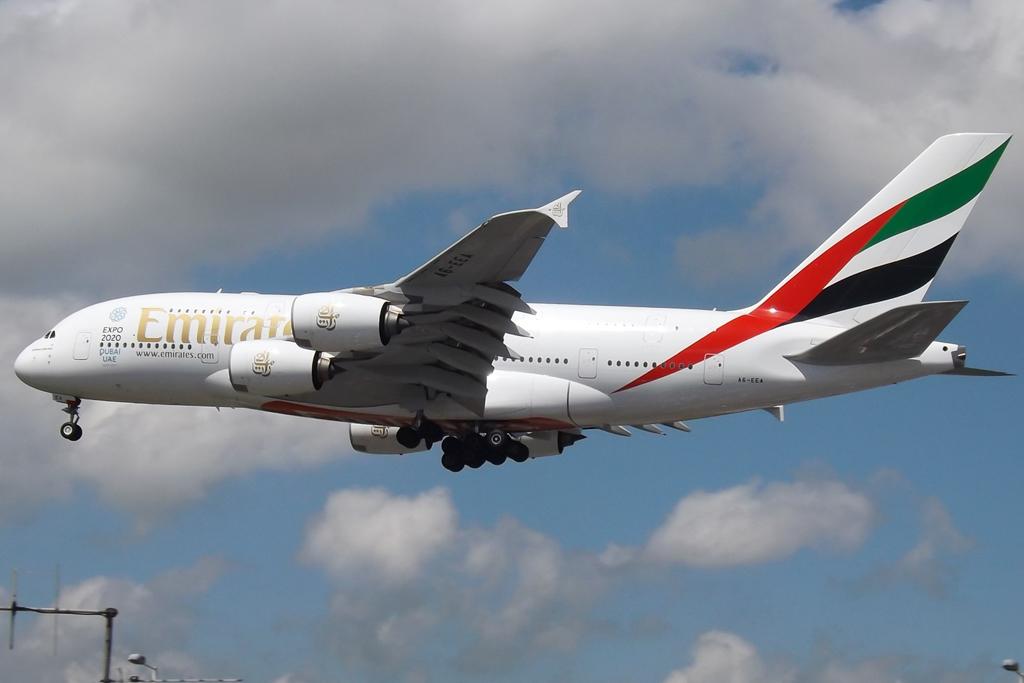What airline is this?
Offer a terse response. Emirates. What color is the name of the airline?
Provide a short and direct response. Gold. 